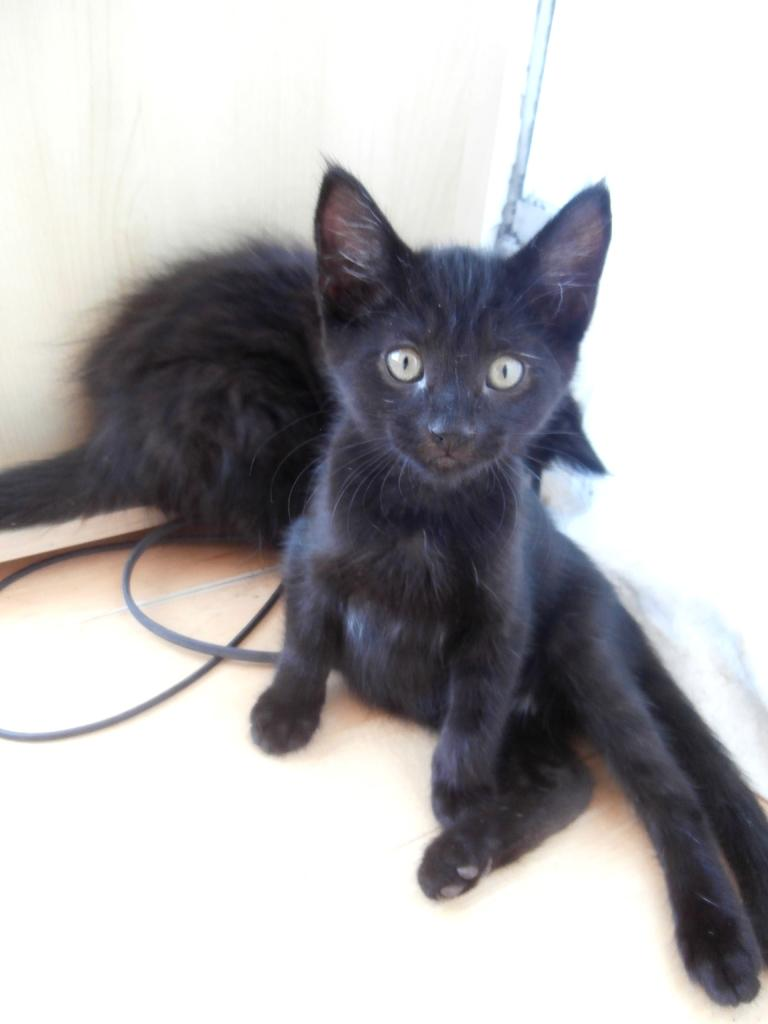How many cats are present in the image? There are 2 black color cats in the image. What color are the cats in the image? The cats are black. What else in the image shares the same color as the cats? There are black color wires in the image. What is the color of the background in the image? The background of the image is white. What type of slave is depicted in the image? There is no depiction of a slave in the image; it features two black cats and black wires against a white background. What type of silk can be seen in the image? There is no silk present in the image. 